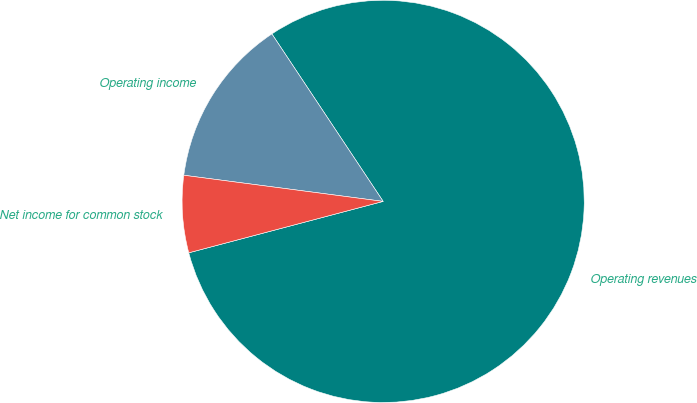Convert chart to OTSL. <chart><loc_0><loc_0><loc_500><loc_500><pie_chart><fcel>Operating revenues<fcel>Operating income<fcel>Net income for common stock<nl><fcel>80.22%<fcel>13.59%<fcel>6.19%<nl></chart> 